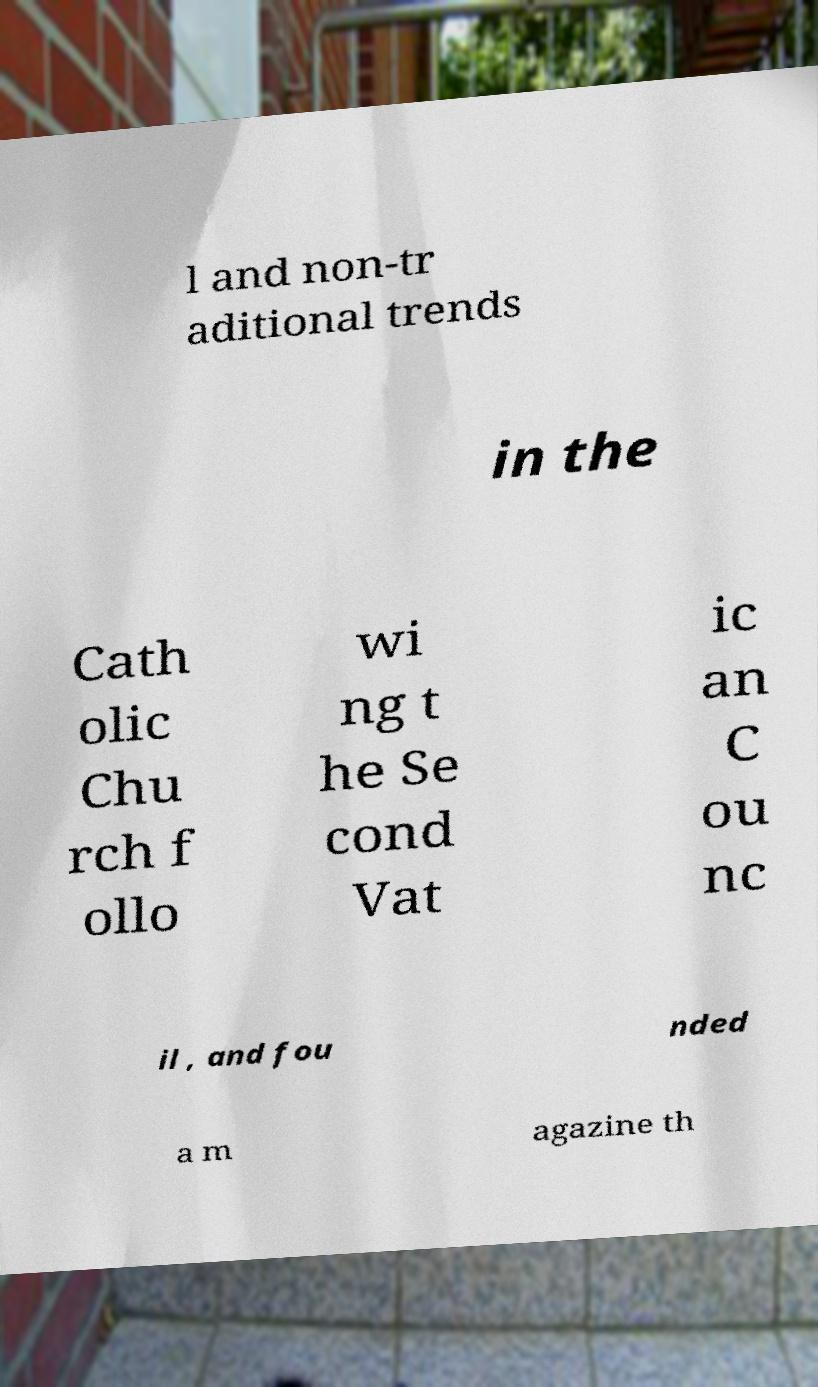There's text embedded in this image that I need extracted. Can you transcribe it verbatim? l and non-tr aditional trends in the Cath olic Chu rch f ollo wi ng t he Se cond Vat ic an C ou nc il , and fou nded a m agazine th 